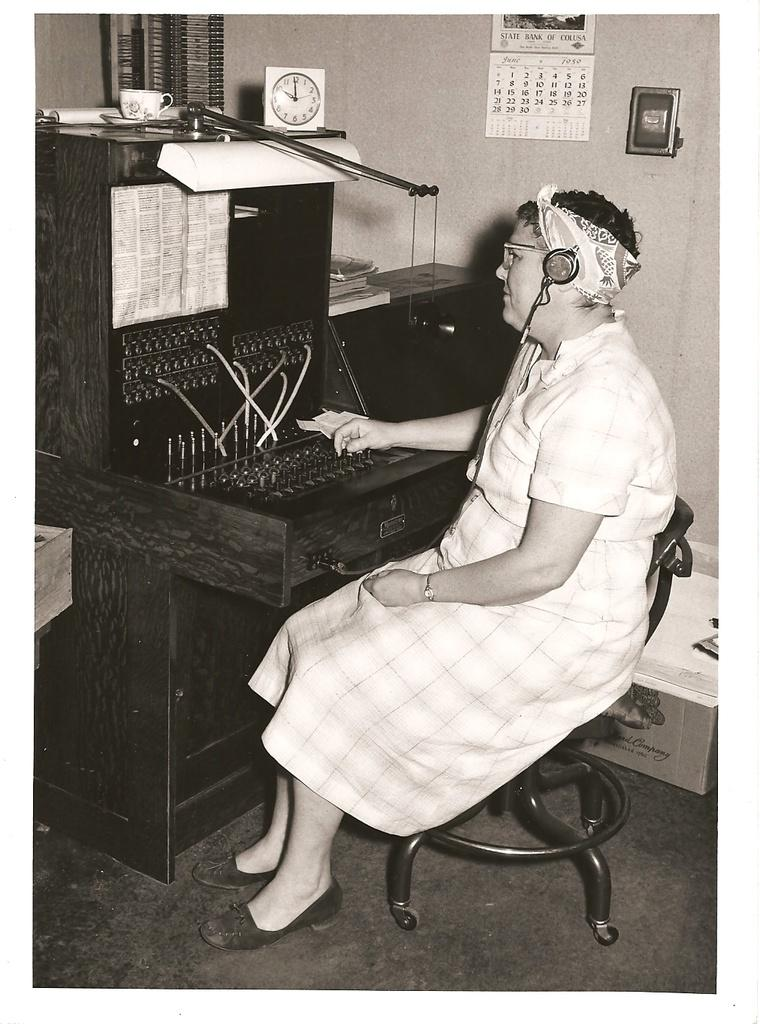What is the woman in the image doing? The woman is sitting on a chair in the image. What is the woman wearing on her ears? The woman is wearing a headphone. What accessory is the woman wearing on her face? The woman is wearing a pair of glasses (specs). What type of object can be seen in the image besides the woman? There is a machine, a cup, and a clock in the image. What type of lettuce is being used as a stem for the woman's glasses in the image? There is no lettuce present in the image, and the woman's glasses do not have a stem made of lettuce. 